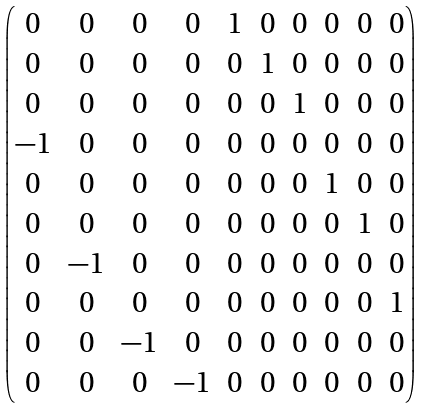Convert formula to latex. <formula><loc_0><loc_0><loc_500><loc_500>\begin{pmatrix} 0 & 0 & 0 & 0 & 1 & 0 & 0 & 0 & 0 & 0 \\ 0 & 0 & 0 & 0 & 0 & 1 & 0 & 0 & 0 & 0 \\ 0 & 0 & 0 & 0 & 0 & 0 & 1 & 0 & 0 & 0 \\ - 1 & 0 & 0 & 0 & 0 & 0 & 0 & 0 & 0 & 0 \\ 0 & 0 & 0 & 0 & 0 & 0 & 0 & 1 & 0 & 0 \\ 0 & 0 & 0 & 0 & 0 & 0 & 0 & 0 & 1 & 0 \\ 0 & - 1 & 0 & 0 & 0 & 0 & 0 & 0 & 0 & 0 \\ 0 & 0 & 0 & 0 & 0 & 0 & 0 & 0 & 0 & 1 \\ 0 & 0 & - 1 & 0 & 0 & 0 & 0 & 0 & 0 & 0 \\ 0 & 0 & 0 & - 1 & 0 & 0 & 0 & 0 & 0 & 0 \\ \end{pmatrix}</formula> 